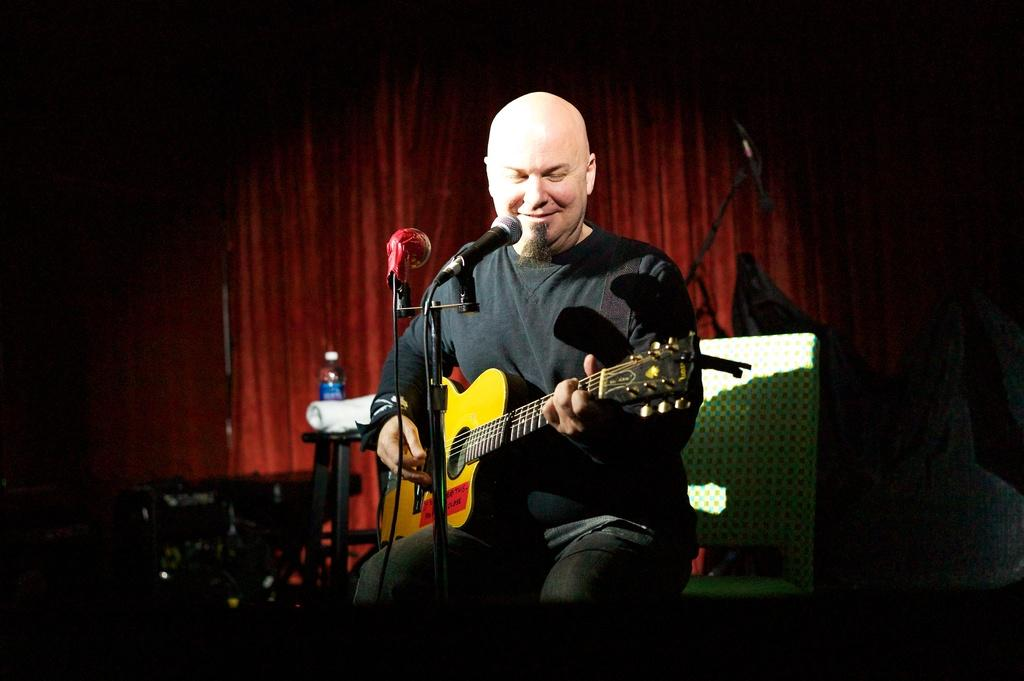What is the person in the image doing? The person is sitting on a chair and playing a guitar. What object is present in the image that is typically used for amplifying sound? There is a microphone in the image. What can be seen on the table in the image? There is a bottle and a cloth on the table. What color is the curtain in the background of the image? There is a red curtain in the background of the image. What month does the person begin their guitar lessons in the image? There is no information about the person's guitar lessons or the month in the image. 